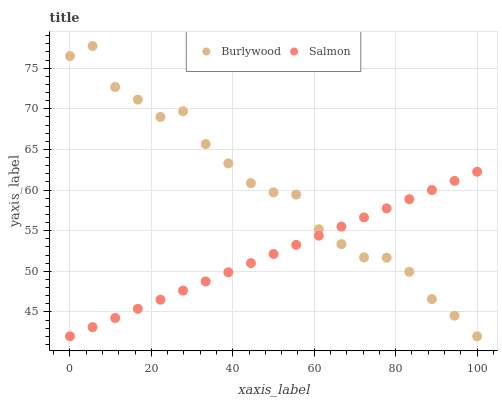Does Salmon have the minimum area under the curve?
Answer yes or no. Yes. Does Burlywood have the maximum area under the curve?
Answer yes or no. Yes. Does Salmon have the maximum area under the curve?
Answer yes or no. No. Is Salmon the smoothest?
Answer yes or no. Yes. Is Burlywood the roughest?
Answer yes or no. Yes. Is Salmon the roughest?
Answer yes or no. No. Does Burlywood have the lowest value?
Answer yes or no. Yes. Does Burlywood have the highest value?
Answer yes or no. Yes. Does Salmon have the highest value?
Answer yes or no. No. Does Salmon intersect Burlywood?
Answer yes or no. Yes. Is Salmon less than Burlywood?
Answer yes or no. No. Is Salmon greater than Burlywood?
Answer yes or no. No. 